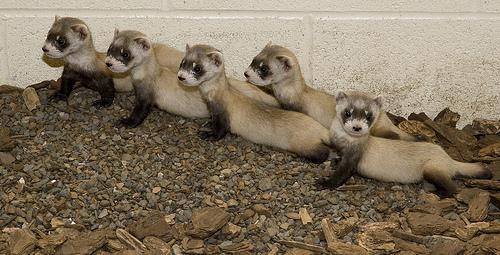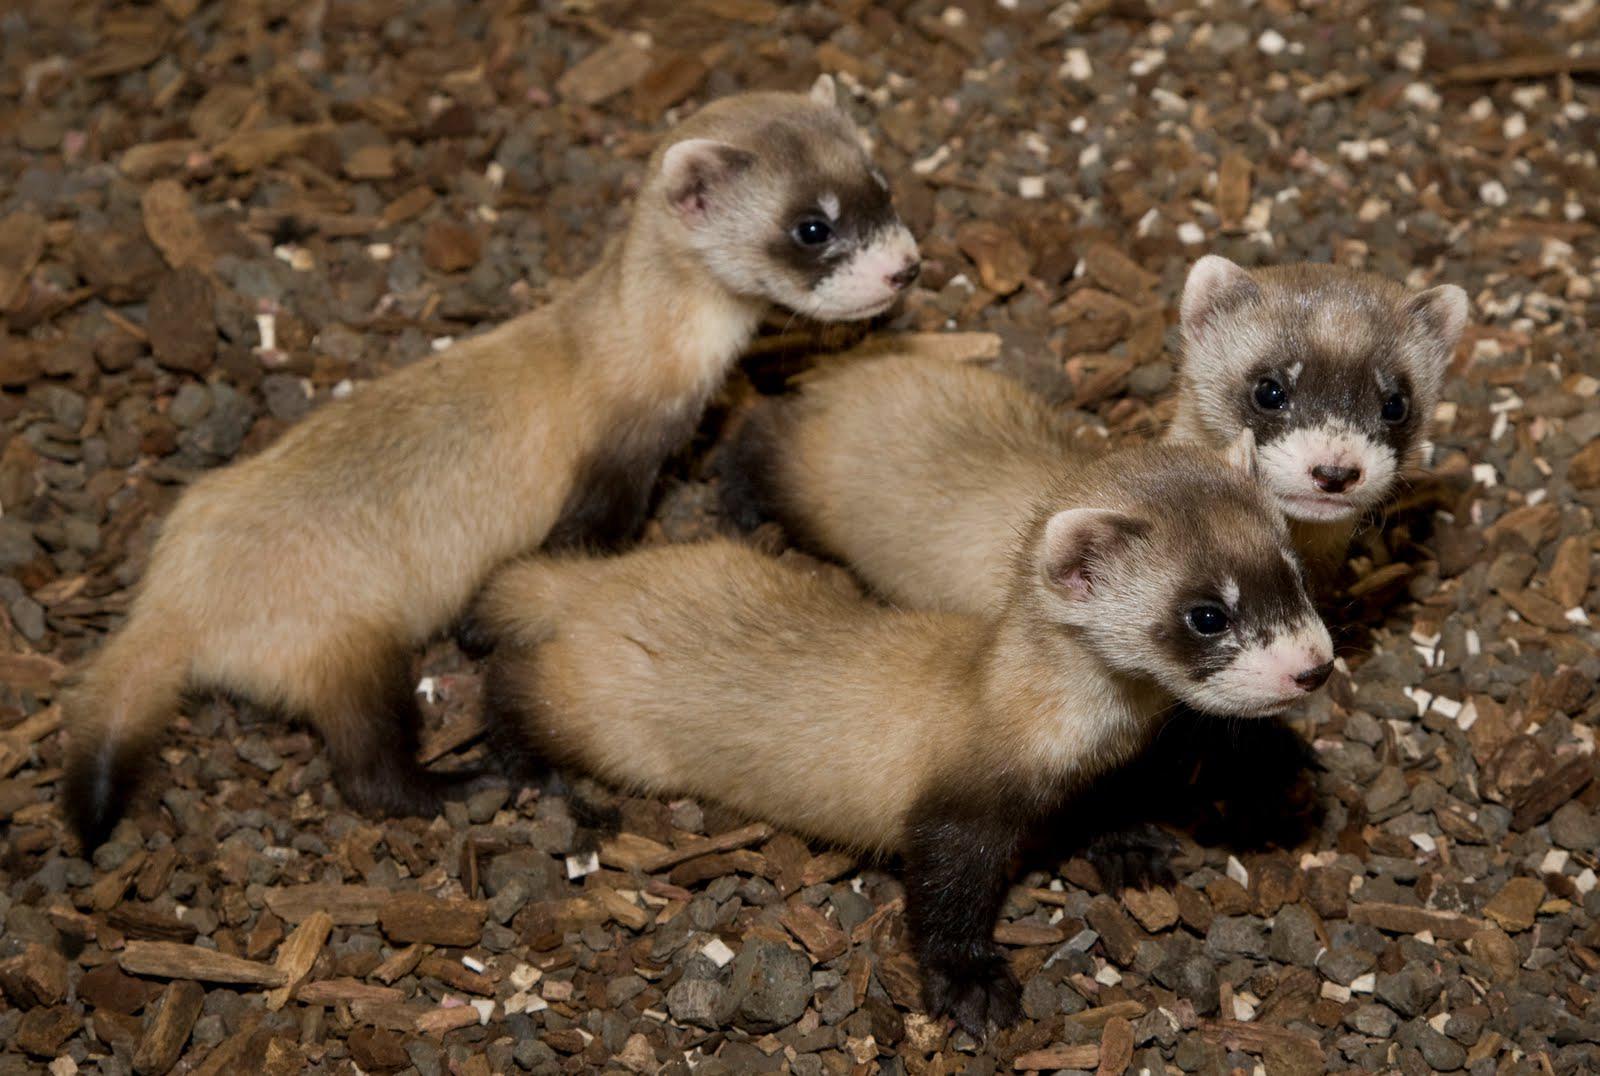The first image is the image on the left, the second image is the image on the right. For the images shown, is this caption "There are exactly five ferrets in the left image." true? Answer yes or no. Yes. The first image is the image on the left, the second image is the image on the right. For the images displayed, is the sentence "There are three ferrets" factually correct? Answer yes or no. No. 